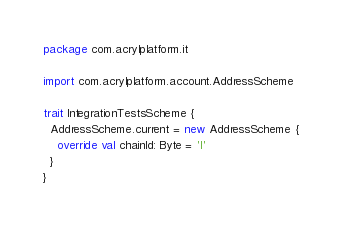Convert code to text. <code><loc_0><loc_0><loc_500><loc_500><_Scala_>package com.acrylplatform.it

import com.acrylplatform.account.AddressScheme

trait IntegrationTestsScheme {
  AddressScheme.current = new AddressScheme {
    override val chainId: Byte = 'I'
  }
}
</code> 